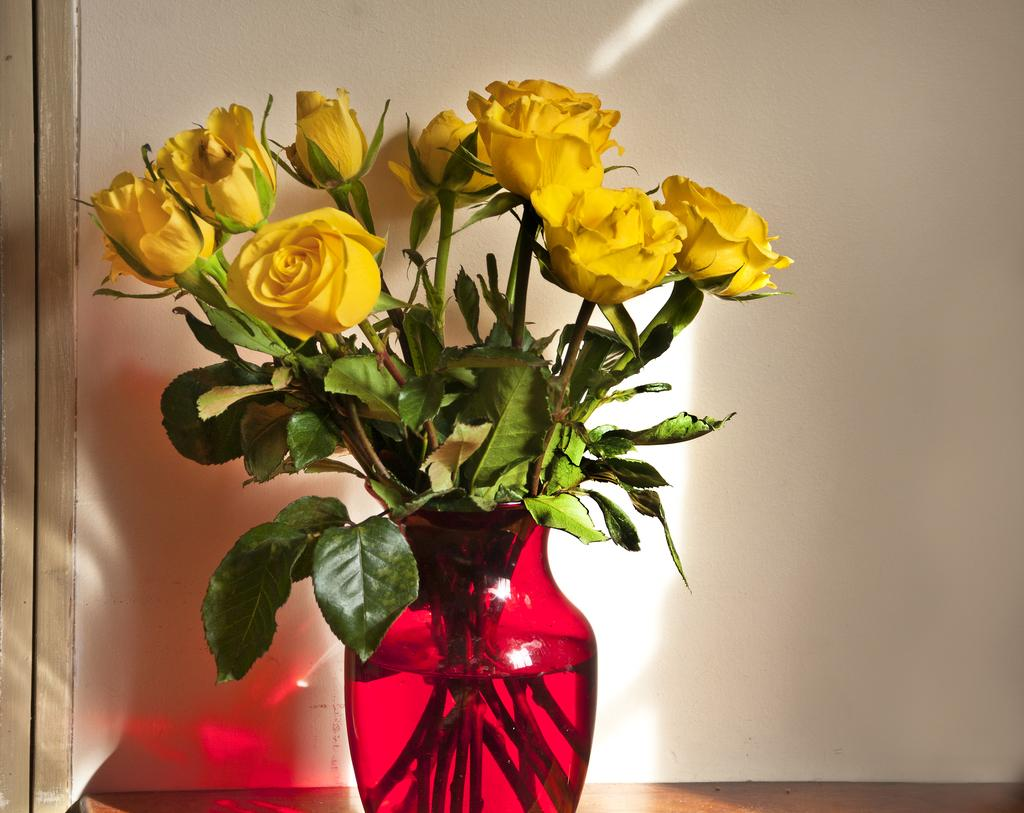What is in the vase that is visible in the image? There are flowers and leaves in the vase in the image. What is the vase filled with? The vase contains water. Where is the vase located in the image? The vase is on a platform. What can be seen in the background of the image? There is a wall visible in the background of the image. How does the potato contribute to the fire in the image? There is no potato or fire present in the image. What is the person attempting to do in the image? There is no person present in the image, so it is not possible to determine what they might be attempting to do. 